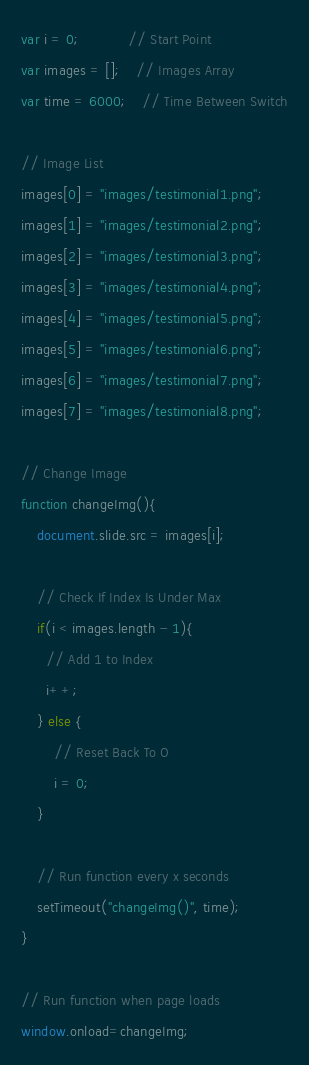<code> <loc_0><loc_0><loc_500><loc_500><_JavaScript_>var i = 0; 			// Start Point
var images = [];	// Images Array
var time = 6000;	// Time Between Switch
	 
// Image List
images[0] = "images/testimonial1.png";
images[1] = "images/testimonial2.png";
images[2] = "images/testimonial3.png";
images[3] = "images/testimonial4.png";
images[4] = "images/testimonial5.png";
images[5] = "images/testimonial6.png";
images[6] = "images/testimonial7.png";
images[7] = "images/testimonial8.png";

// Change Image
function changeImg(){
	document.slide.src = images[i];

	// Check If Index Is Under Max
	if(i < images.length - 1){
	  // Add 1 to Index
	  i++; 
	} else { 
		// Reset Back To O
		i = 0;
	}

	// Run function every x seconds
	setTimeout("changeImg()", time);
}

// Run function when page loads
window.onload=changeImg;
</code> 